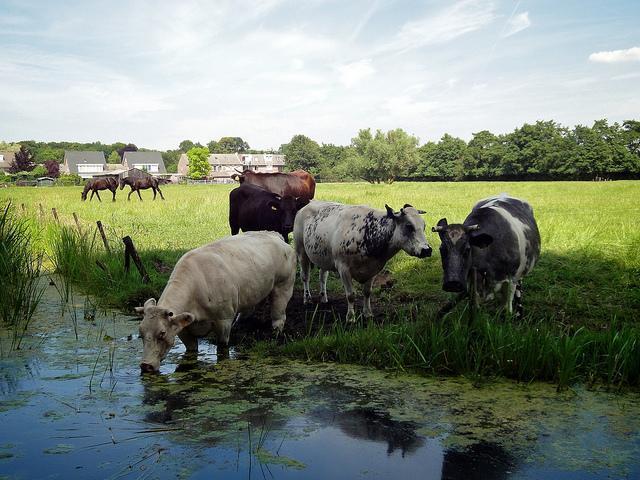How many of these bulls are drinking?
Give a very brief answer. 1. How many horns does the cow have?
Give a very brief answer. 2. How many cows are visible?
Give a very brief answer. 4. How many people are wearing blue?
Give a very brief answer. 0. 